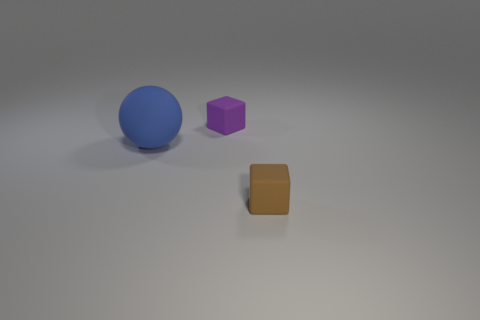Is there anything else that is the same size as the matte sphere?
Your answer should be very brief. No. How many matte objects are to the right of the blue matte sphere and behind the small brown matte block?
Keep it short and to the point. 1. What number of large purple spheres are the same material as the large blue sphere?
Offer a terse response. 0. What color is the sphere that is the same material as the small purple block?
Ensure brevity in your answer.  Blue. Are there fewer matte cubes than purple matte blocks?
Provide a short and direct response. No. Does the rubber block that is behind the tiny brown rubber object have the same color as the object on the right side of the purple matte block?
Keep it short and to the point. No. Is the number of small purple things greater than the number of matte cubes?
Ensure brevity in your answer.  No. What color is the other thing that is the same shape as the brown rubber thing?
Offer a terse response. Purple. What is the object that is on the left side of the brown block and to the right of the ball made of?
Give a very brief answer. Rubber. Do the small purple object that is behind the blue ball and the tiny object in front of the big blue ball have the same material?
Make the answer very short. Yes. 